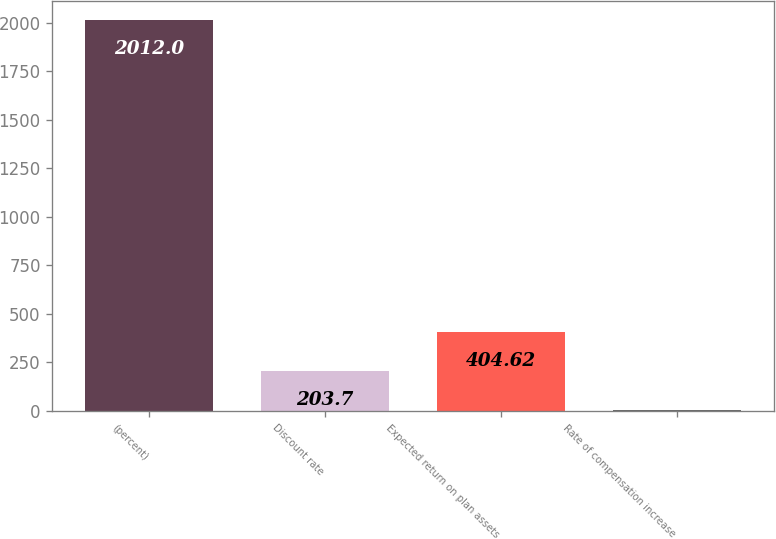Convert chart to OTSL. <chart><loc_0><loc_0><loc_500><loc_500><bar_chart><fcel>(percent)<fcel>Discount rate<fcel>Expected return on plan assets<fcel>Rate of compensation increase<nl><fcel>2012<fcel>203.7<fcel>404.62<fcel>2.78<nl></chart> 